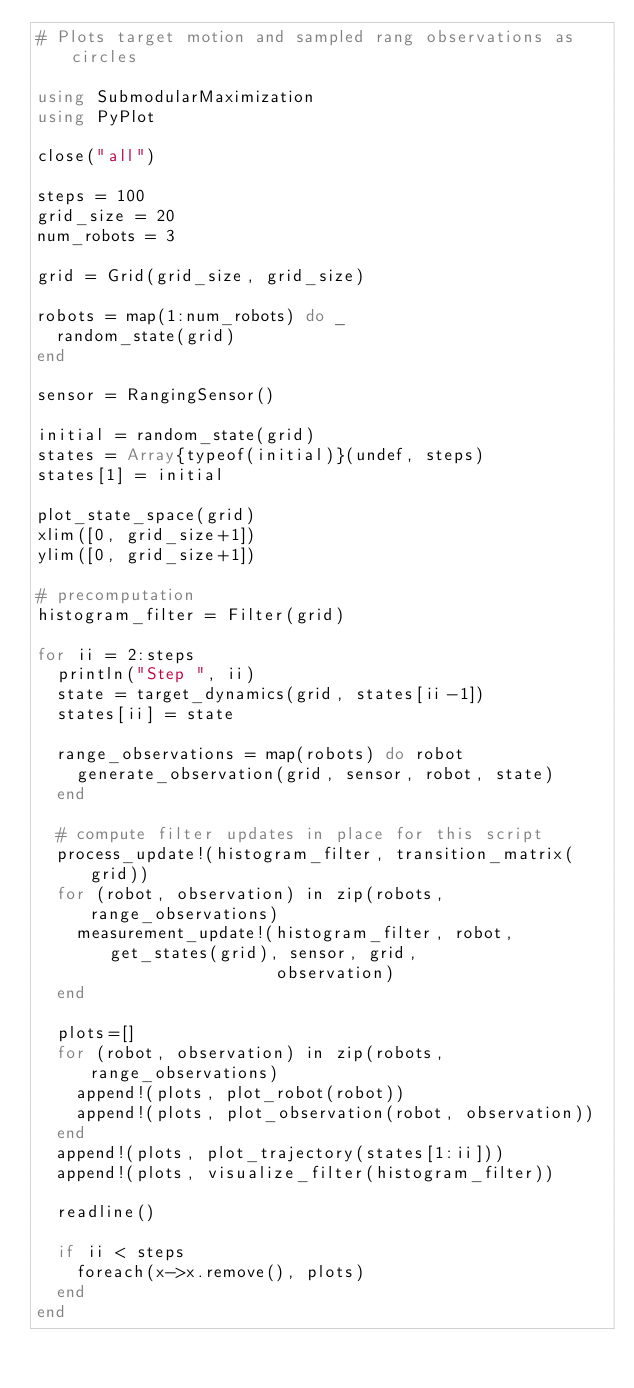<code> <loc_0><loc_0><loc_500><loc_500><_Julia_># Plots target motion and sampled rang observations as circles

using SubmodularMaximization
using PyPlot

close("all")

steps = 100
grid_size = 20
num_robots = 3

grid = Grid(grid_size, grid_size)

robots = map(1:num_robots) do _
  random_state(grid)
end

sensor = RangingSensor()

initial = random_state(grid)
states = Array{typeof(initial)}(undef, steps)
states[1] = initial

plot_state_space(grid)
xlim([0, grid_size+1])
ylim([0, grid_size+1])

# precomputation
histogram_filter = Filter(grid)

for ii = 2:steps
  println("Step ", ii)
  state = target_dynamics(grid, states[ii-1])
  states[ii] = state

  range_observations = map(robots) do robot
    generate_observation(grid, sensor, robot, state)
  end

  # compute filter updates in place for this script
  process_update!(histogram_filter, transition_matrix(grid))
  for (robot, observation) in zip(robots, range_observations)
    measurement_update!(histogram_filter, robot, get_states(grid), sensor, grid,
                        observation)
  end

  plots=[]
  for (robot, observation) in zip(robots, range_observations)
    append!(plots, plot_robot(robot))
    append!(plots, plot_observation(robot, observation))
  end
  append!(plots, plot_trajectory(states[1:ii]))
  append!(plots, visualize_filter(histogram_filter))

  readline()

  if ii < steps
    foreach(x->x.remove(), plots)
  end
end
</code> 